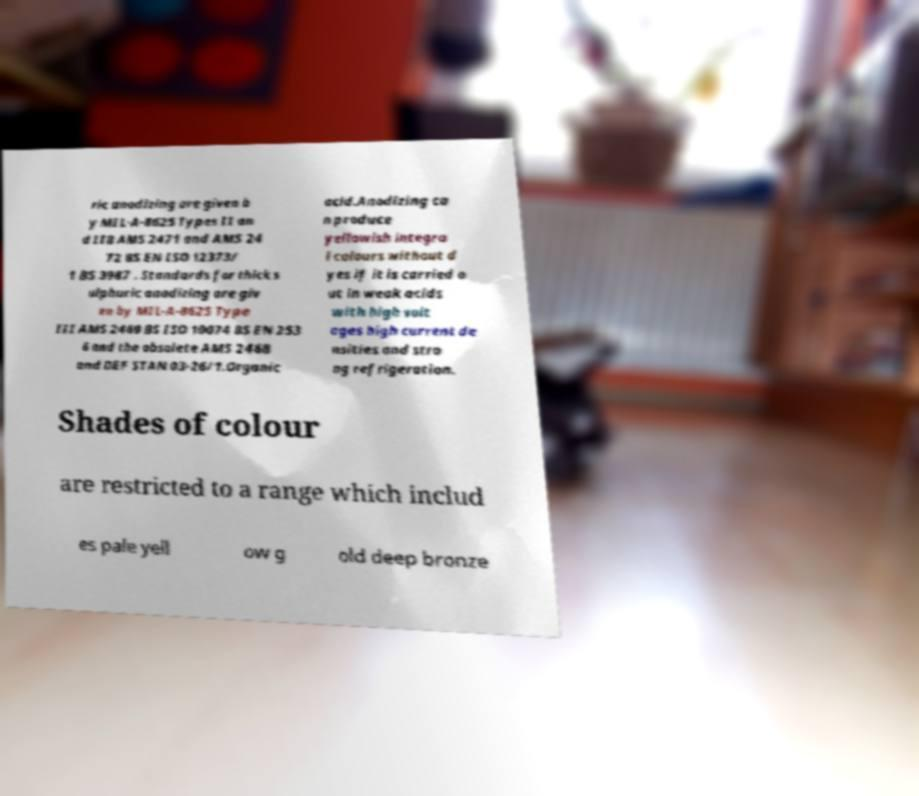Please read and relay the text visible in this image. What does it say? ric anodizing are given b y MIL-A-8625 Types II an d IIB AMS 2471 and AMS 24 72 BS EN ISO 12373/ 1 BS 3987 . Standards for thick s ulphuric anodizing are giv en by MIL-A-8625 Type III AMS 2469 BS ISO 10074 BS EN 253 6 and the obsolete AMS 2468 and DEF STAN 03-26/1.Organic acid.Anodizing ca n produce yellowish integra l colours without d yes if it is carried o ut in weak acids with high volt ages high current de nsities and stro ng refrigeration. Shades of colour are restricted to a range which includ es pale yell ow g old deep bronze 